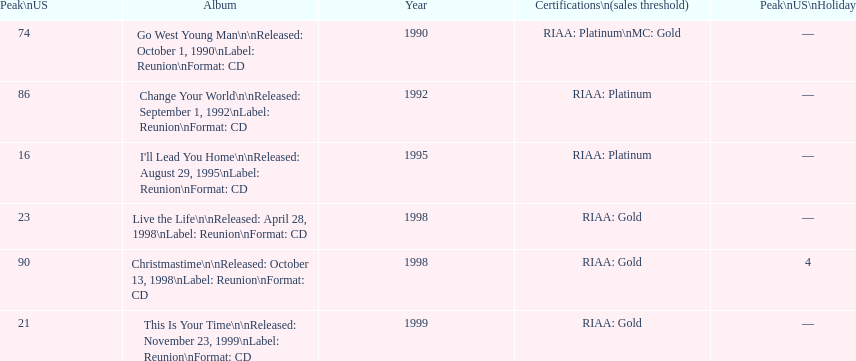How many songs are listed from 1998? 2. 